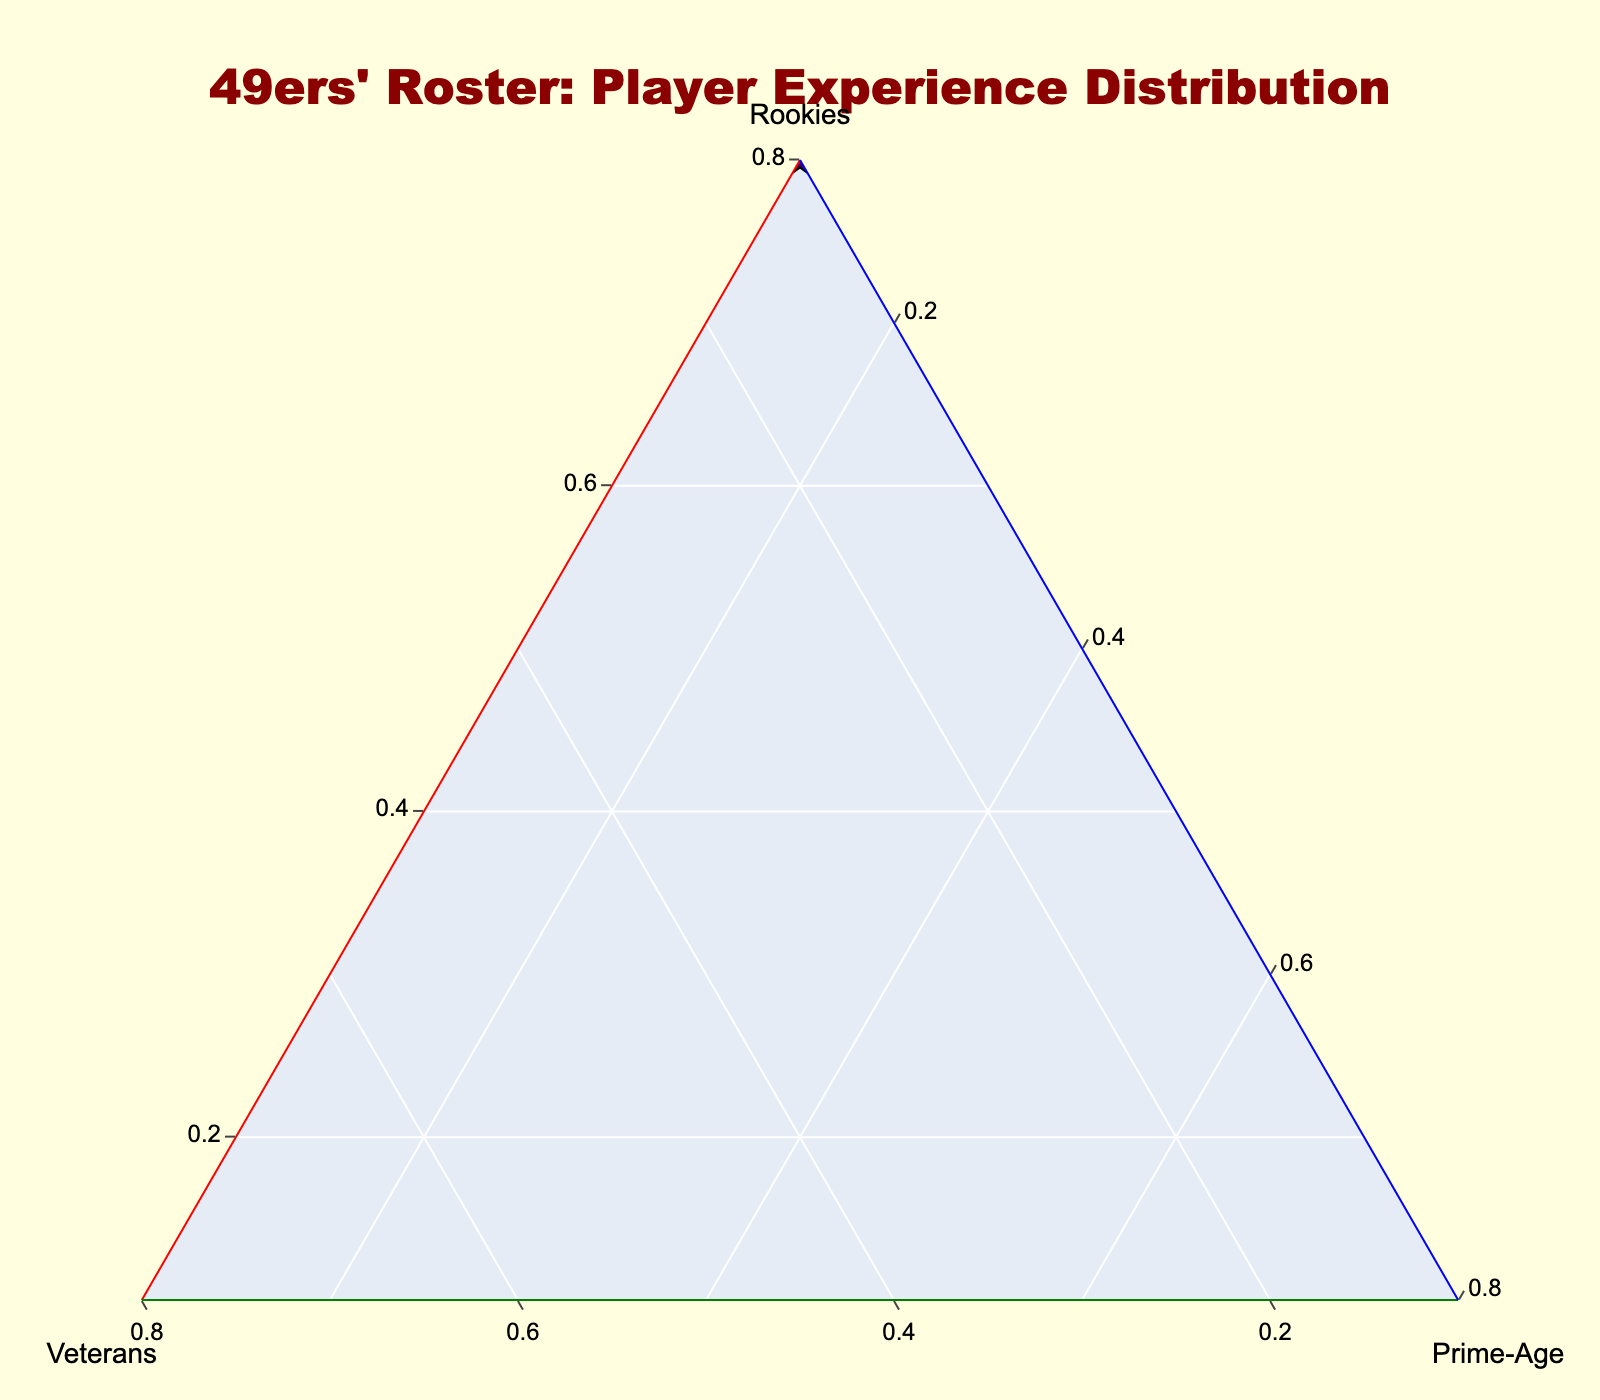What's the title of the plot? The title is usually placed at the top of the plot and should be clearly visible in larger or bold font.
Answer: "49ers' Roster: Player Experience Distribution" Which player has the highest representation in the Prime-Age category? In a ternary plot, you look for the data point that is closest to the Prime-Age axis. The player closest to the Prime-Age axis has the highest representation in this category.
Answer: Nick Bosa What is the ratio between Rookies and Prime-Age for Brock Purdy? For ratios, you compare the numerical values of the two categories. Brock Purdy has 0.8 for Rookies and 0.1 for Prime-Age. The ratio is 0.8:0.1 or 8:1.
Answer: 8:1 How many players have a Veteran representation of 0.6 or higher? Review each data point's Veteran value to count how many meet or exceed 0.6. The players are George Kittle, Trent Williams, and Jake Brendel.
Answer: 3 Which player has an equal representation of Rookies and Prime-Age? Look for a data point where the Rookie and Prime-Age values are exactly the same. Jordan Mason has 0.5 for both Rookies and Prime-Age.
Answer: Jordan Mason Among Fred Warner, Deebo Samuel, and Christian McCaffrey, who has the highest Prime-Age representation? Compare the Prime-Age values of the three players. Deebo Samuel has 0.8, Fred Warner has 0.6, and Christian McCaffrey has 0.7.
Answer: Deebo Samuel What's the difference in Veteran representation between George Kittle and Javon Hargrave? Subtract the Veteran value of Javon Hargrave (0.5) from George Kittle (0.6), resulting in a difference of 0.1.
Answer: 0.1 Which player is closest to having an equal distribution of experience across all three categories? Talanoa Hufanga has 0.2 Rookies, 0.0 Veterans, and 0.8 Prime-Age. Although this is not perfectly equal, it shows a mixed distribution compared to other players who lean heavily towards a single category.
Answer: Talanoa Hufanga 